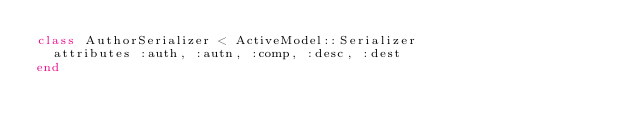Convert code to text. <code><loc_0><loc_0><loc_500><loc_500><_Ruby_>class AuthorSerializer < ActiveModel::Serializer
  attributes :auth, :autn, :comp, :desc, :dest
end
</code> 